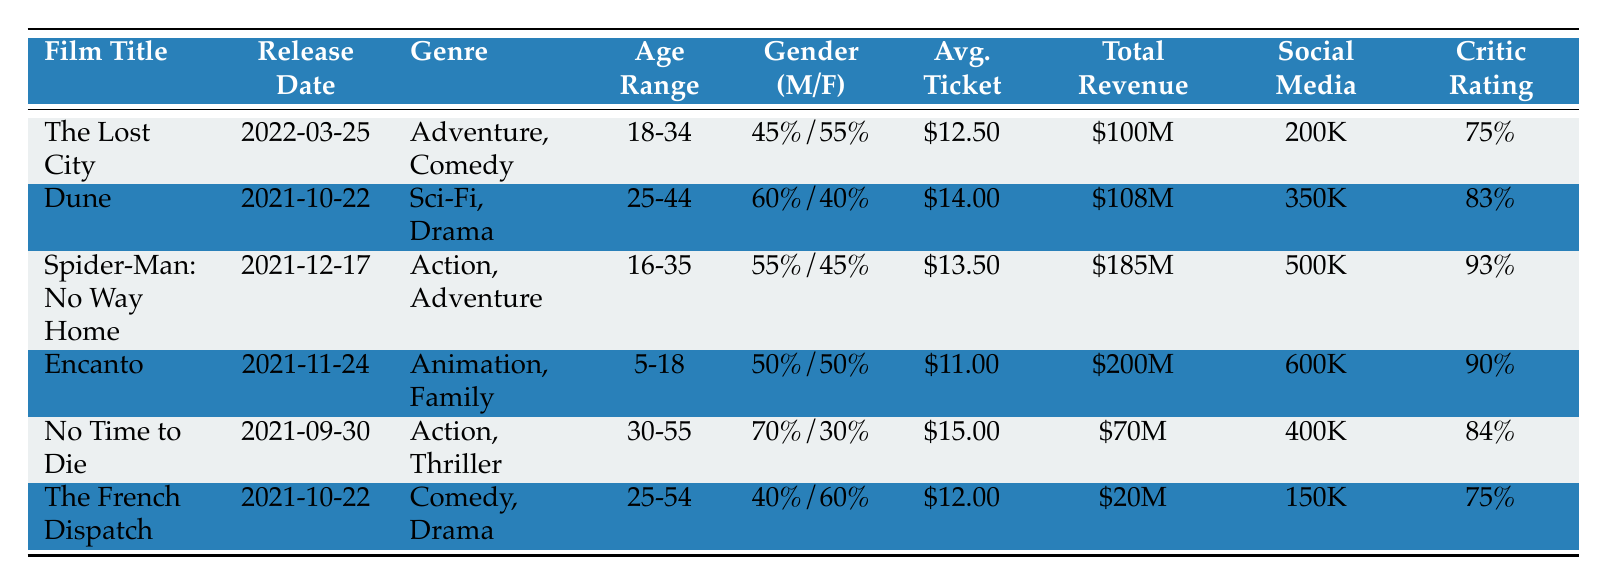What is the average ticket price for "The Lost City"? The average ticket price for "The Lost City," as mentioned in the table, is \$12.50.
Answer: \$12.50 Which film had the highest total revenue? The total revenues for the films are as follows: "Encanto" - \$200M, "Spider-Man: No Way Home" - \$185M, "Dune" - \$108M, "The Lost City" - \$100M, "No Time to Die" - \$70M, "The French Dispatch" - \$20M. "Encanto" has the highest revenue at \$200M.
Answer: "Encanto" What is the gender distribution for "Dune"? The gender distribution for "Dune" is 60% Male and 40% Female as indicated in the table.
Answer: 60% Male, 40% Female Is the critical rating of "Spider-Man: No Way Home" higher than 90%? The critical rating for "Spider-Man: No Way Home" is 93%, which is indeed higher than 90%.
Answer: Yes What is the average ticket price for the films in the Action genre? The average ticket prices for Action films are as follows: "Spider-Man: No Way Home" - \$13.50 and "No Time to Die" - \$15.00. Adding those gives \$13.50 + \$15.00 = \$28.50, and there are 2 films, so the average is \$28.50 / 2 = \$14.25.
Answer: \$14.25 Which age range includes the largest audience for the featured films? The age ranges and their corresponding films are: "18-34" (1 film), "25-44" (1 film), "16-35" (1 film), "5-18" (1 film), "30-55" (1 film), and "25-54" (1 film). Each age range has only one film, so there is no single largest age range group.
Answer: None (All equal) What percentage of the audience in "The French Dispatch" is female? The gender distribution for "The French Dispatch" shows that 60% of the audience is female.
Answer: 60% What film has both the lowest average ticket price and the lowest total revenue? "Encanto" has the lowest average ticket price at \$11.00 and "The French Dispatch" has the lowest total revenue at \$20M. Since "The French Dispatch" has the lowest total revenue, it is the answer.
Answer: "The French Dispatch" Which film had more social media engagement, “No Time to Die” or “Dune”? "No Time to Die" had 400K likes and "Dune" had 350K likes. Since 400K > 350K, "No Time to Die" had more likes.
Answer: "No Time to Die" How do the average ticket prices compare between the Genre "Animation, Family" and "Sci-Fi, Drama"? The average ticket price for "Encanto" (Animation, Family) is \$11.00, while for "Dune" (Sci-Fi, Drama) it is \$14.00. Comparing these, \$11.00 is less than \$14.00.
Answer: Animation, Family is less expensive 